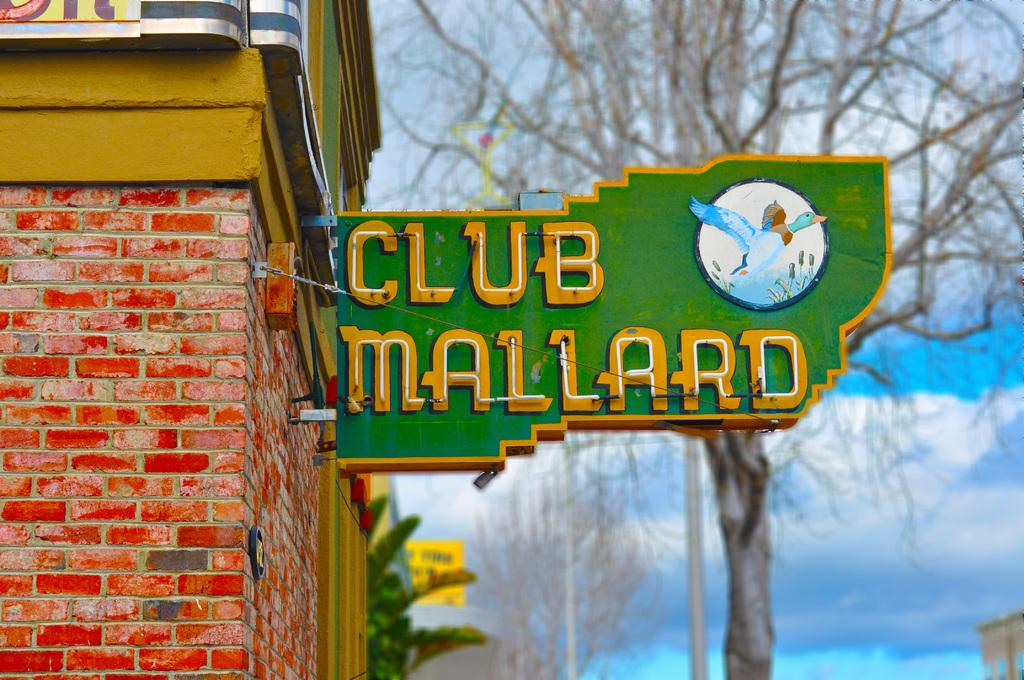What type of structure is present in the image? There is a building in the image. What can be found on the building? There is a name board on the building. What other elements are visible in the image? There is a wall and a tree in the image. What is the color of the sky in the image? The sky is visible in the image, and it is blue. Can you see a wren perched on the tree in the image? There is no wren present in the image. What type of support is the building using to stay upright? The image does not provide information about the building's support structure. Is there a whip visible in the image? There is no whip present in the image. 